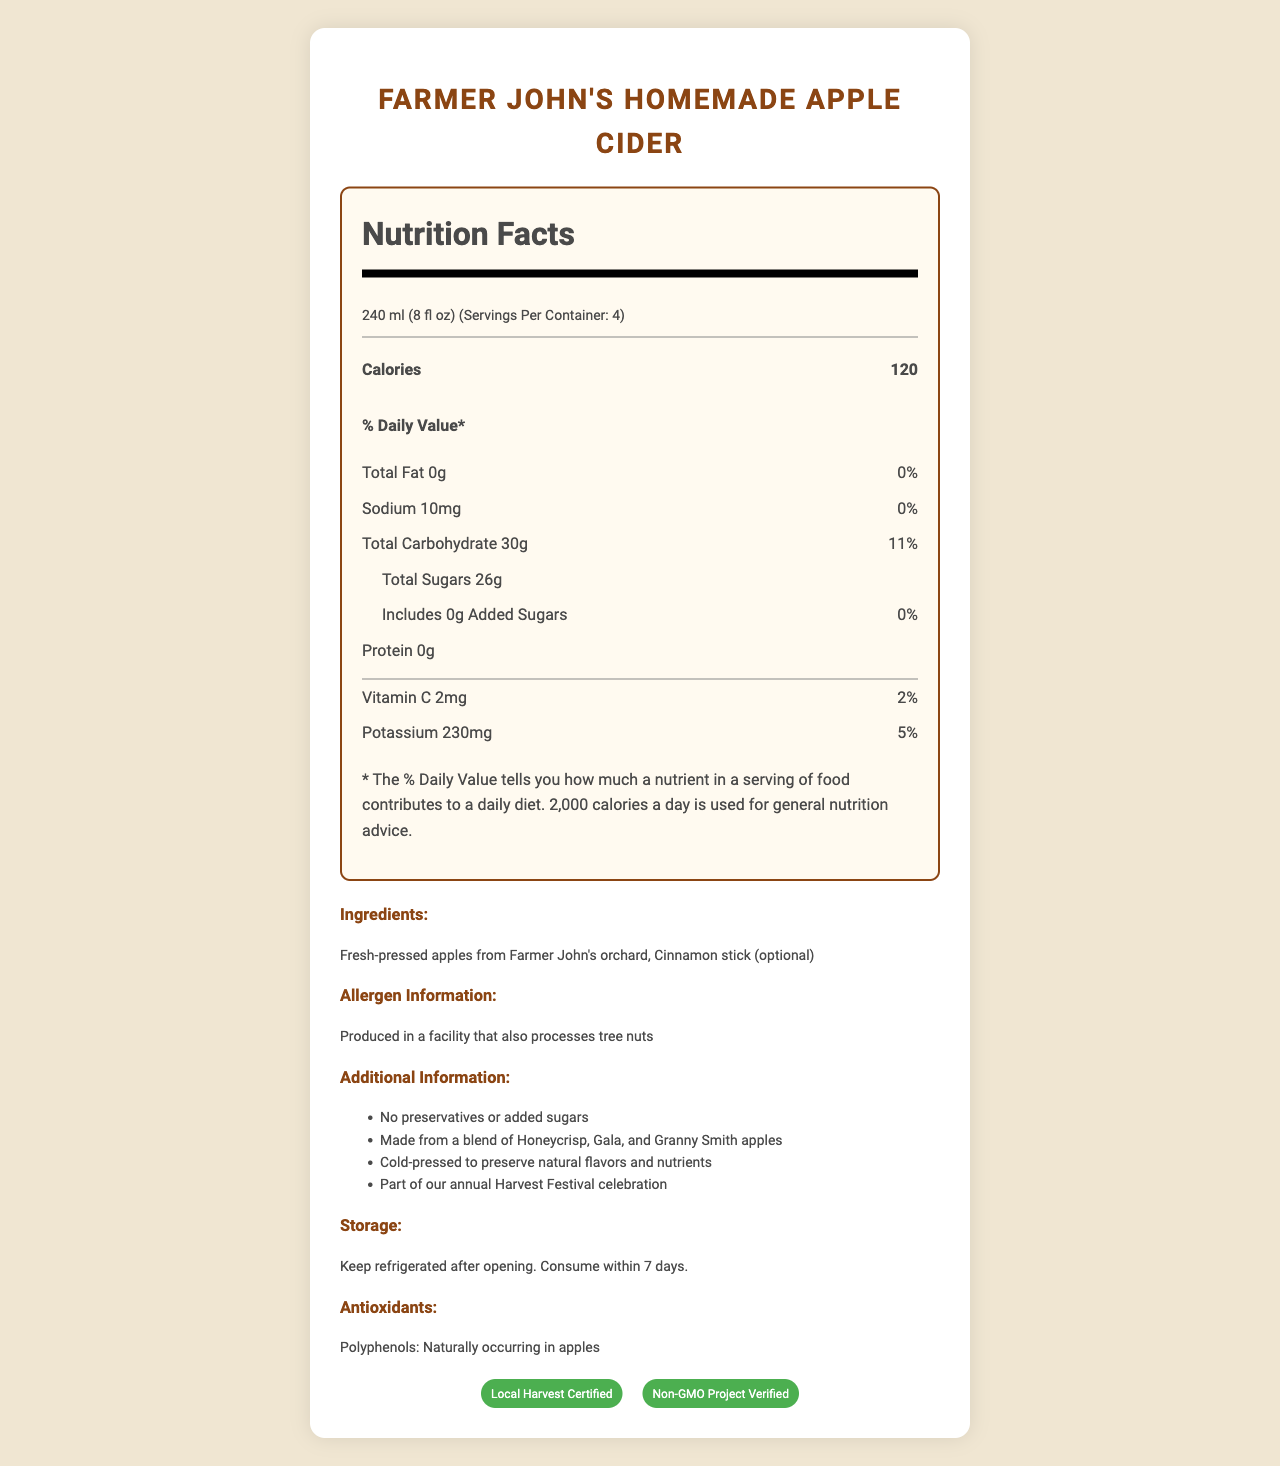what is the serving size of Farmer John's Homemade Apple Cider? The nutrition label specifies the serving size as 240 ml (8 fl oz).
Answer: 240 ml (8 fl oz) how many calories are in one serving? The label clearly states that there are 120 calories in one serving.
Answer: 120 calories what is the source of the sugars in Farmer John's Homemade Apple Cider? The document states that the cider contains no added sugars, implying the sugars come from the fresh-pressed apples.
Answer: Fresh-pressed apples how long can you keep the cider refrigerated after opening? The storage instructions mention that the cider should be consumed within 7 days of opening.
Answer: 7 days what are the natural antioxidants found in the cider called? The label notes that the cider contains naturally occurring polyphenols from apples.
Answer: Polyphenols which of the following ingredients is optional in the cider? A. Fresh-pressed apples, B. Cinnamon stick, C. Honeycrisp apples The document lists "Cinnamon stick (optional)" as one of the ingredients.
Answer: B what is the daily value percentage of potassium in one serving? A. 2%, B. 5%, C. 11% The label states that the daily value percentage of potassium is 5%.
Answer: B does the cider contain any preservatives? The additional information clearly indicates that there are no preservatives in the cider.
Answer: No is the cider suitable for someone with a nut allergy? The allergen information states the product is made in a facility that processes tree nuts, so it may not be suitable for someone with a nut allergy.
Answer: No what is the main idea of the document? The document is a comprehensive nutrition facts label with information on serving size, calorie content, and various nutrients, as well as ingredients, allergens, storage instructions, and certifications.
Answer: The document provides detailed nutritional information and additional facts about Farmer John's Homemade Apple Cider. It highlights the natural ingredients, lack of preservatives, and health benefits such as natural sugars and antioxidants. what is the LDL (bad) cholesterol content in the cider? The label does not provide any information about LDL (bad) cholesterol content.
Answer: Not enough information 